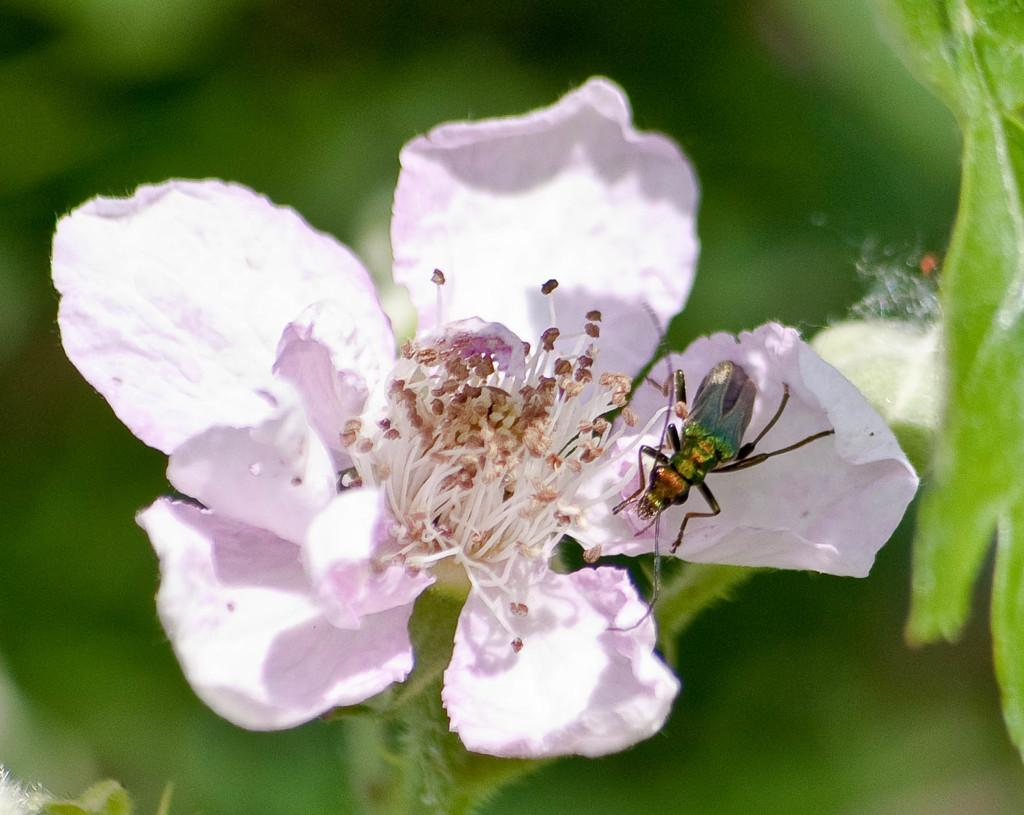What is the main subject of the image? There is a flower in the image. What are the characteristics of the flower? The flower has petals and pollen grains. Is there any other living organism present in the image? Yes, there is an insect on the flower. How would you describe the background of the image? The background of the image appears green and blurry. Reasoning: Let' Let's think step by step in order to produce the conversation. We start by identifying the main subject of the image, which is the flower. Then, we describe the characteristics of the flower, including its petals and pollen grains. Next, we mention the presence of an insect on the flower, which adds another layer of detail to the image. Finally, we describe the background of the image, noting its green and blurry appearance. Absurd Question/Answer: What type of cast can be seen on the street in the image? There is no cast or street present in the image; it features a flower, insect, and a green and blurry background. 